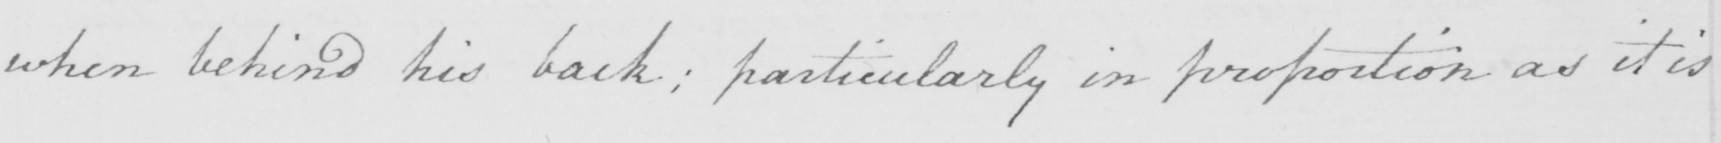Please transcribe the handwritten text in this image. when behind his back ; particularly in proportion as it is 